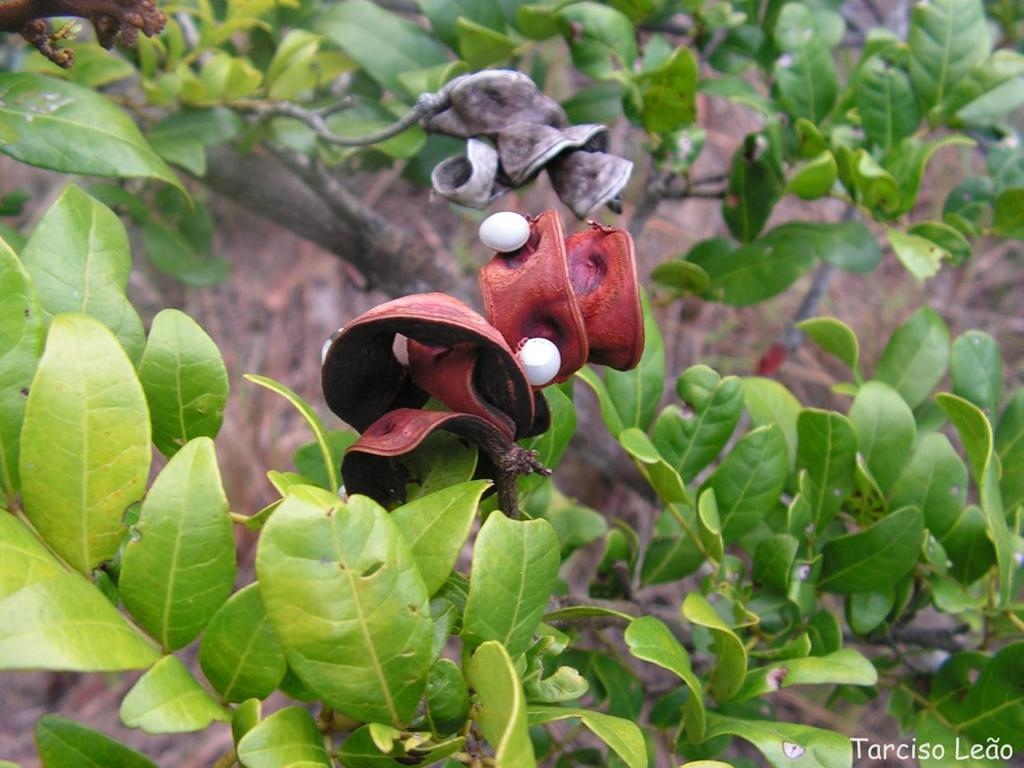What colors are the objects in the image? The objects in the image are brown and white colored. What is located near the objects in the image? The objects are near a green plant. Can you describe the background of the image? The background of the image is blurry. Can you see any mountains or yaks in the image? There are no mountains or yaks present in the image. Is there a collar visible on the objects in the image? There is no collar visible on the objects in the image. 